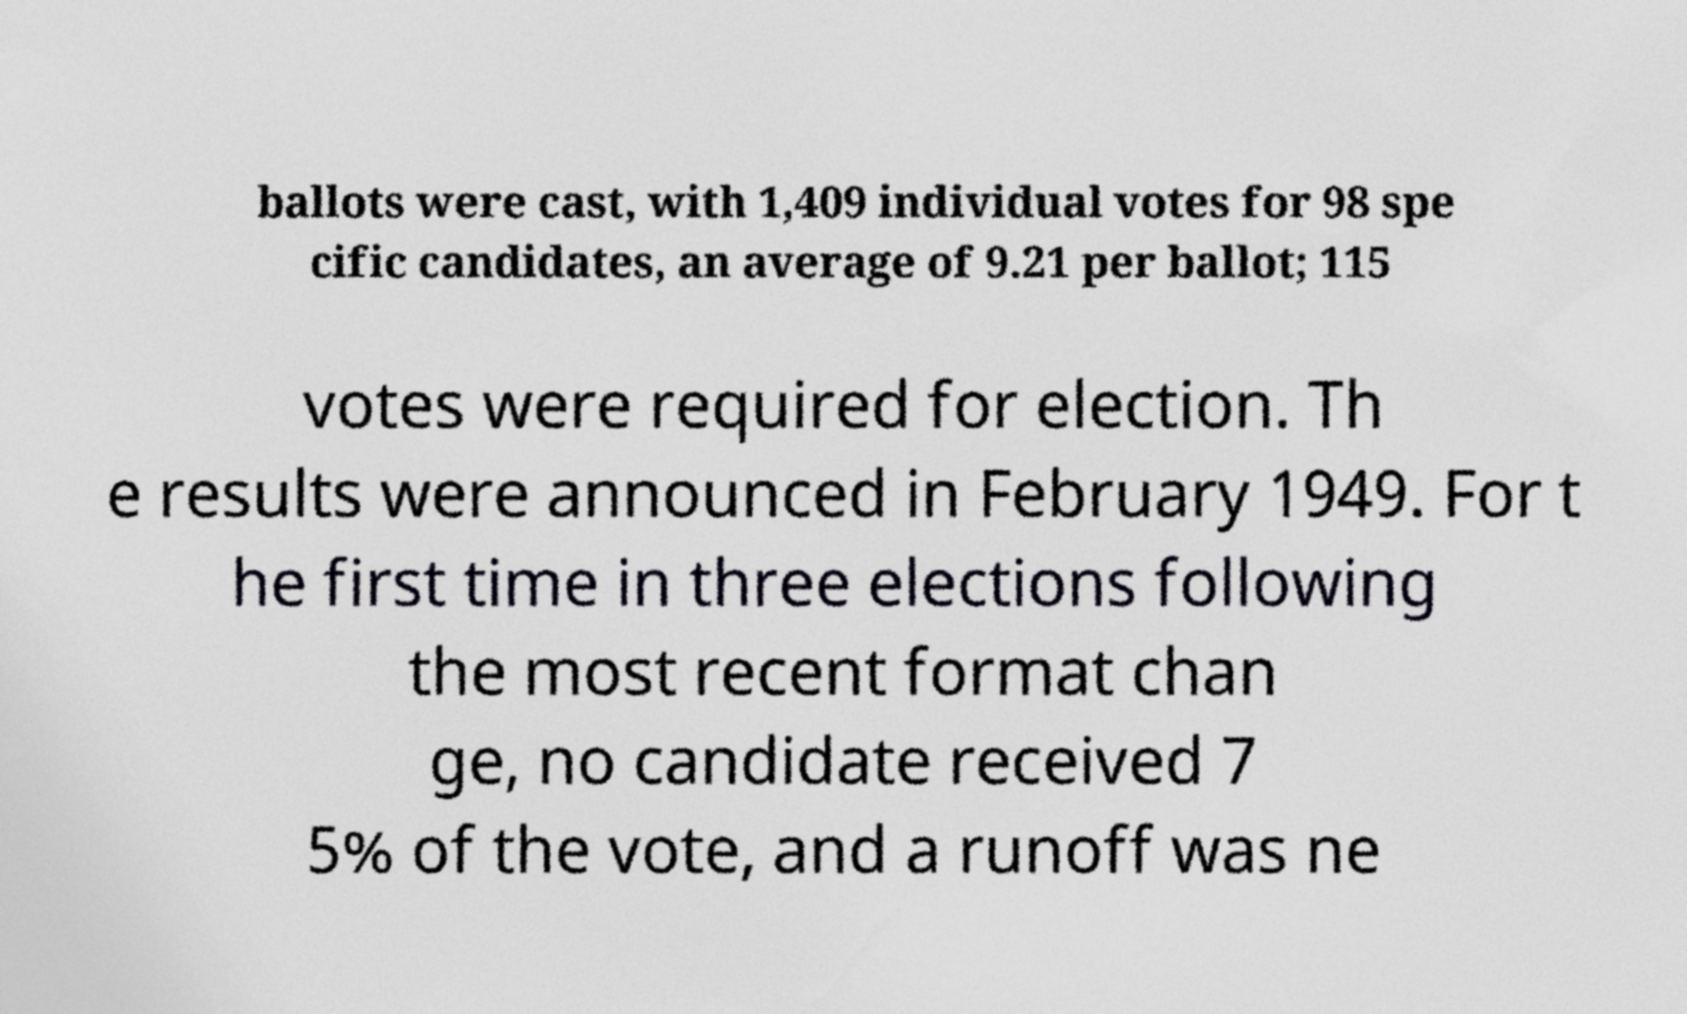For documentation purposes, I need the text within this image transcribed. Could you provide that? ballots were cast, with 1,409 individual votes for 98 spe cific candidates, an average of 9.21 per ballot; 115 votes were required for election. Th e results were announced in February 1949. For t he first time in three elections following the most recent format chan ge, no candidate received 7 5% of the vote, and a runoff was ne 